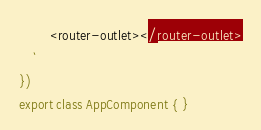Convert code to text. <code><loc_0><loc_0><loc_500><loc_500><_TypeScript_>		<router-outlet></router-outlet>
	`
})
export class AppComponent { }
</code> 